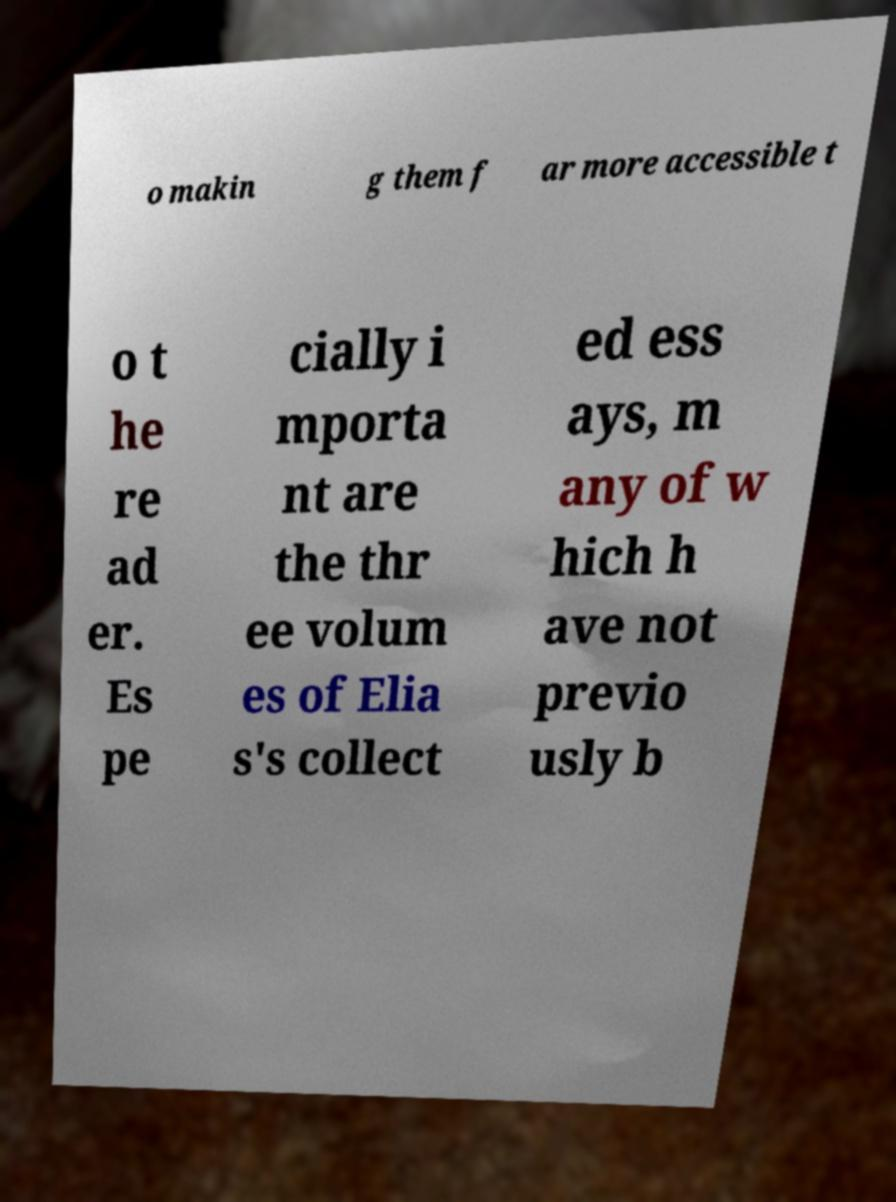There's text embedded in this image that I need extracted. Can you transcribe it verbatim? o makin g them f ar more accessible t o t he re ad er. Es pe cially i mporta nt are the thr ee volum es of Elia s's collect ed ess ays, m any of w hich h ave not previo usly b 